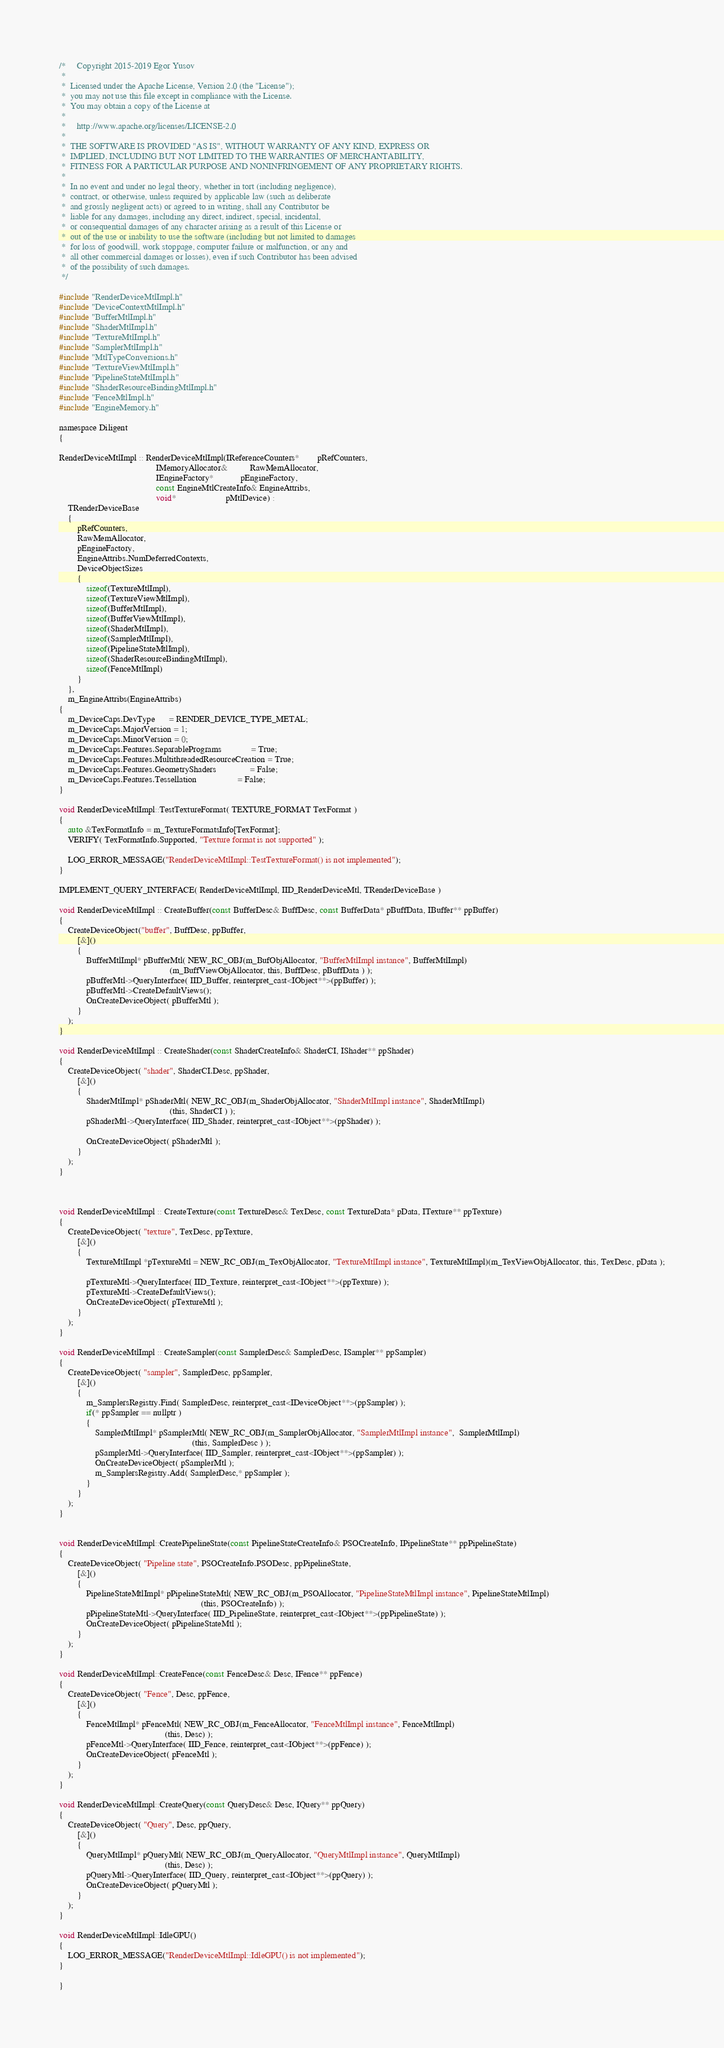<code> <loc_0><loc_0><loc_500><loc_500><_ObjectiveC_>/*     Copyright 2015-2019 Egor Yusov
 *  
 *  Licensed under the Apache License, Version 2.0 (the "License");
 *  you may not use this file except in compliance with the License.
 *  You may obtain a copy of the License at
 * 
 *     http://www.apache.org/licenses/LICENSE-2.0
 * 
 *  THE SOFTWARE IS PROVIDED "AS IS", WITHOUT WARRANTY OF ANY KIND, EXPRESS OR
 *  IMPLIED, INCLUDING BUT NOT LIMITED TO THE WARRANTIES OF MERCHANTABILITY,
 *  FITNESS FOR A PARTICULAR PURPOSE AND NONINFRINGEMENT OF ANY PROPRIETARY RIGHTS.
 *
 *  In no event and under no legal theory, whether in tort (including negligence), 
 *  contract, or otherwise, unless required by applicable law (such as deliberate 
 *  and grossly negligent acts) or agreed to in writing, shall any Contributor be
 *  liable for any damages, including any direct, indirect, special, incidental, 
 *  or consequential damages of any character arising as a result of this License or 
 *  out of the use or inability to use the software (including but not limited to damages 
 *  for loss of goodwill, work stoppage, computer failure or malfunction, or any and 
 *  all other commercial damages or losses), even if such Contributor has been advised 
 *  of the possibility of such damages.
 */

#include "RenderDeviceMtlImpl.h"
#include "DeviceContextMtlImpl.h"
#include "BufferMtlImpl.h"
#include "ShaderMtlImpl.h"
#include "TextureMtlImpl.h"
#include "SamplerMtlImpl.h"
#include "MtlTypeConversions.h"
#include "TextureViewMtlImpl.h"
#include "PipelineStateMtlImpl.h"
#include "ShaderResourceBindingMtlImpl.h"
#include "FenceMtlImpl.h"
#include "EngineMemory.h"

namespace Diligent
{

RenderDeviceMtlImpl :: RenderDeviceMtlImpl(IReferenceCounters*        pRefCounters,
                                           IMemoryAllocator&          RawMemAllocator,
                                           IEngineFactory*            pEngineFactory,
                                           const EngineMtlCreateInfo& EngineAttribs,
                                           void*                      pMtlDevice) : 
    TRenderDeviceBase
    {
        pRefCounters,
        RawMemAllocator,
        pEngineFactory,
        EngineAttribs.NumDeferredContexts,
        DeviceObjectSizes
        {
            sizeof(TextureMtlImpl),
            sizeof(TextureViewMtlImpl),
            sizeof(BufferMtlImpl),
            sizeof(BufferViewMtlImpl),
            sizeof(ShaderMtlImpl),
            sizeof(SamplerMtlImpl),
            sizeof(PipelineStateMtlImpl),
            sizeof(ShaderResourceBindingMtlImpl),
            sizeof(FenceMtlImpl)
        }
    },
    m_EngineAttribs(EngineAttribs)
{
    m_DeviceCaps.DevType      = RENDER_DEVICE_TYPE_METAL;
    m_DeviceCaps.MajorVersion = 1;
    m_DeviceCaps.MinorVersion = 0;
    m_DeviceCaps.Features.SeparablePrograms             = True;
    m_DeviceCaps.Features.MultithreadedResourceCreation = True;
    m_DeviceCaps.Features.GeometryShaders               = False;
    m_DeviceCaps.Features.Tessellation                  = False;
}

void RenderDeviceMtlImpl::TestTextureFormat( TEXTURE_FORMAT TexFormat )
{
    auto &TexFormatInfo = m_TextureFormatsInfo[TexFormat];
    VERIFY( TexFormatInfo.Supported, "Texture format is not supported" );

    LOG_ERROR_MESSAGE("RenderDeviceMtlImpl::TestTextureFormat() is not implemented");
}

IMPLEMENT_QUERY_INTERFACE( RenderDeviceMtlImpl, IID_RenderDeviceMtl, TRenderDeviceBase )

void RenderDeviceMtlImpl :: CreateBuffer(const BufferDesc& BuffDesc, const BufferData* pBuffData, IBuffer** ppBuffer)
{
    CreateDeviceObject("buffer", BuffDesc, ppBuffer, 
        [&]()
        {
            BufferMtlImpl* pBufferMtl( NEW_RC_OBJ(m_BufObjAllocator, "BufferMtlImpl instance", BufferMtlImpl)
                                                 (m_BuffViewObjAllocator, this, BuffDesc, pBuffData ) );
            pBufferMtl->QueryInterface( IID_Buffer, reinterpret_cast<IObject**>(ppBuffer) );
            pBufferMtl->CreateDefaultViews();
            OnCreateDeviceObject( pBufferMtl );
        } 
    );
}

void RenderDeviceMtlImpl :: CreateShader(const ShaderCreateInfo& ShaderCI, IShader** ppShader)
{
    CreateDeviceObject( "shader", ShaderCI.Desc, ppShader, 
        [&]()
        {
            ShaderMtlImpl* pShaderMtl( NEW_RC_OBJ(m_ShaderObjAllocator, "ShaderMtlImpl instance", ShaderMtlImpl)
                                                 (this, ShaderCI ) );
            pShaderMtl->QueryInterface( IID_Shader, reinterpret_cast<IObject**>(ppShader) );

            OnCreateDeviceObject( pShaderMtl );
        } 
    );
}



void RenderDeviceMtlImpl :: CreateTexture(const TextureDesc& TexDesc, const TextureData* pData, ITexture** ppTexture)
{
    CreateDeviceObject( "texture", TexDesc, ppTexture, 
        [&]()
        {
            TextureMtlImpl *pTextureMtl = NEW_RC_OBJ(m_TexObjAllocator, "TextureMtlImpl instance", TextureMtlImpl)(m_TexViewObjAllocator, this, TexDesc, pData );

            pTextureMtl->QueryInterface( IID_Texture, reinterpret_cast<IObject**>(ppTexture) );
            pTextureMtl->CreateDefaultViews();
            OnCreateDeviceObject( pTextureMtl );
        } 
    );
}

void RenderDeviceMtlImpl :: CreateSampler(const SamplerDesc& SamplerDesc, ISampler** ppSampler)
{
    CreateDeviceObject( "sampler", SamplerDesc, ppSampler, 
        [&]()
        {
            m_SamplersRegistry.Find( SamplerDesc, reinterpret_cast<IDeviceObject**>(ppSampler) );
            if(* ppSampler == nullptr )
            {
                SamplerMtlImpl* pSamplerMtl( NEW_RC_OBJ(m_SamplerObjAllocator, "SamplerMtlImpl instance",  SamplerMtlImpl)
                                                           (this, SamplerDesc ) );
                pSamplerMtl->QueryInterface( IID_Sampler, reinterpret_cast<IObject**>(ppSampler) );
                OnCreateDeviceObject( pSamplerMtl );
                m_SamplersRegistry.Add( SamplerDesc,* ppSampler );
            }
        }
    );
}


void RenderDeviceMtlImpl::CreatePipelineState(const PipelineStateCreateInfo& PSOCreateInfo, IPipelineState** ppPipelineState)
{
    CreateDeviceObject( "Pipeline state", PSOCreateInfo.PSODesc, ppPipelineState, 
        [&]()
        {
            PipelineStateMtlImpl* pPipelineStateMtl( NEW_RC_OBJ(m_PSOAllocator, "PipelineStateMtlImpl instance", PipelineStateMtlImpl)
                                                               (this, PSOCreateInfo) );
            pPipelineStateMtl->QueryInterface( IID_PipelineState, reinterpret_cast<IObject**>(ppPipelineState) );
            OnCreateDeviceObject( pPipelineStateMtl );
        } 
    );
}

void RenderDeviceMtlImpl::CreateFence(const FenceDesc& Desc, IFence** ppFence)
{
    CreateDeviceObject( "Fence", Desc, ppFence, 
        [&]()
        {
            FenceMtlImpl* pFenceMtl( NEW_RC_OBJ(m_FenceAllocator, "FenceMtlImpl instance", FenceMtlImpl)
                                               (this, Desc) );
            pFenceMtl->QueryInterface( IID_Fence, reinterpret_cast<IObject**>(ppFence) );
            OnCreateDeviceObject( pFenceMtl );
        }
    );
}

void RenderDeviceMtlImpl::CreateQuery(const QueryDesc& Desc, IQuery** ppQuery)
{
    CreateDeviceObject( "Query", Desc, ppQuery, 
        [&]()
        {
            QueryMtlImpl* pQueryMtl( NEW_RC_OBJ(m_QueryAllocator, "QueryMtlImpl instance", QueryMtlImpl)
                                               (this, Desc) );
            pQueryMtl->QueryInterface( IID_Query, reinterpret_cast<IObject**>(ppQuery) );
            OnCreateDeviceObject( pQueryMtl );
        }
    );
}

void RenderDeviceMtlImpl::IdleGPU()
{
    LOG_ERROR_MESSAGE("RenderDeviceMtlImpl::IdleGPU() is not implemented");
}

}
</code> 